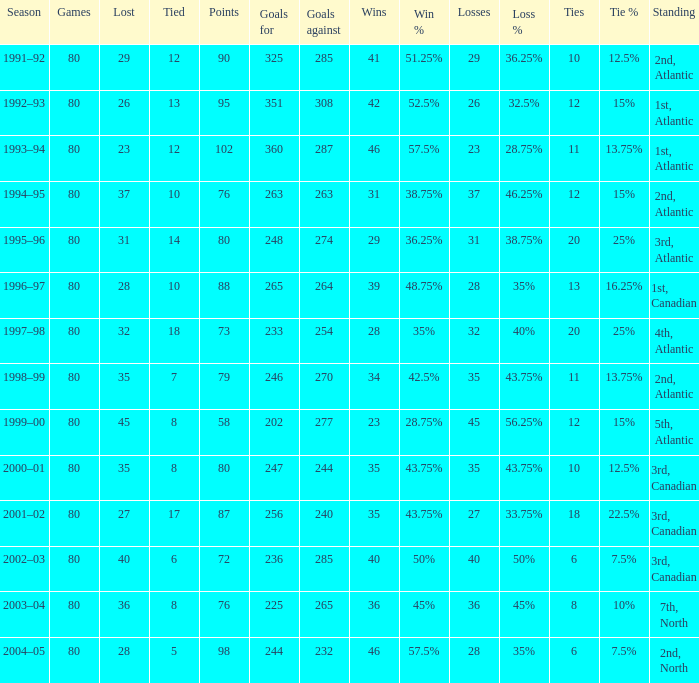How many goals against have 58 points? 277.0. 